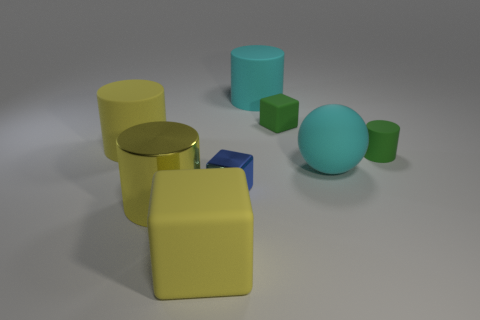Subtract all small blocks. How many blocks are left? 1 Subtract all green cylinders. How many cylinders are left? 3 Subtract all balls. How many objects are left? 7 Add 1 green matte objects. How many objects exist? 9 Subtract 2 cubes. How many cubes are left? 1 Add 8 rubber spheres. How many rubber spheres are left? 9 Add 7 green cubes. How many green cubes exist? 8 Subtract 0 red balls. How many objects are left? 8 Subtract all brown cubes. Subtract all red cylinders. How many cubes are left? 3 Subtract all blue balls. How many cyan cubes are left? 0 